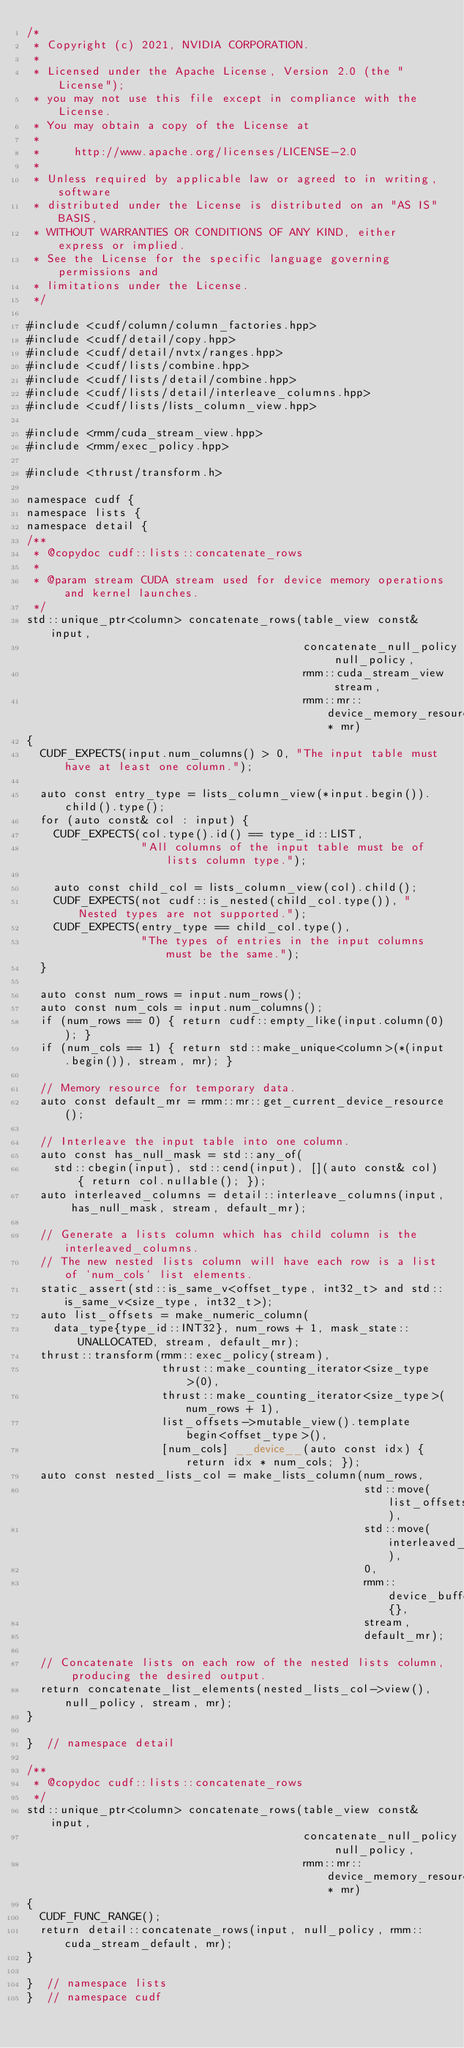<code> <loc_0><loc_0><loc_500><loc_500><_Cuda_>/*
 * Copyright (c) 2021, NVIDIA CORPORATION.
 *
 * Licensed under the Apache License, Version 2.0 (the "License");
 * you may not use this file except in compliance with the License.
 * You may obtain a copy of the License at
 *
 *     http://www.apache.org/licenses/LICENSE-2.0
 *
 * Unless required by applicable law or agreed to in writing, software
 * distributed under the License is distributed on an "AS IS" BASIS,
 * WITHOUT WARRANTIES OR CONDITIONS OF ANY KIND, either express or implied.
 * See the License for the specific language governing permissions and
 * limitations under the License.
 */

#include <cudf/column/column_factories.hpp>
#include <cudf/detail/copy.hpp>
#include <cudf/detail/nvtx/ranges.hpp>
#include <cudf/lists/combine.hpp>
#include <cudf/lists/detail/combine.hpp>
#include <cudf/lists/detail/interleave_columns.hpp>
#include <cudf/lists/lists_column_view.hpp>

#include <rmm/cuda_stream_view.hpp>
#include <rmm/exec_policy.hpp>

#include <thrust/transform.h>

namespace cudf {
namespace lists {
namespace detail {
/**
 * @copydoc cudf::lists::concatenate_rows
 *
 * @param stream CUDA stream used for device memory operations and kernel launches.
 */
std::unique_ptr<column> concatenate_rows(table_view const& input,
                                         concatenate_null_policy null_policy,
                                         rmm::cuda_stream_view stream,
                                         rmm::mr::device_memory_resource* mr)
{
  CUDF_EXPECTS(input.num_columns() > 0, "The input table must have at least one column.");

  auto const entry_type = lists_column_view(*input.begin()).child().type();
  for (auto const& col : input) {
    CUDF_EXPECTS(col.type().id() == type_id::LIST,
                 "All columns of the input table must be of lists column type.");

    auto const child_col = lists_column_view(col).child();
    CUDF_EXPECTS(not cudf::is_nested(child_col.type()), "Nested types are not supported.");
    CUDF_EXPECTS(entry_type == child_col.type(),
                 "The types of entries in the input columns must be the same.");
  }

  auto const num_rows = input.num_rows();
  auto const num_cols = input.num_columns();
  if (num_rows == 0) { return cudf::empty_like(input.column(0)); }
  if (num_cols == 1) { return std::make_unique<column>(*(input.begin()), stream, mr); }

  // Memory resource for temporary data.
  auto const default_mr = rmm::mr::get_current_device_resource();

  // Interleave the input table into one column.
  auto const has_null_mask = std::any_of(
    std::cbegin(input), std::cend(input), [](auto const& col) { return col.nullable(); });
  auto interleaved_columns = detail::interleave_columns(input, has_null_mask, stream, default_mr);

  // Generate a lists column which has child column is the interleaved_columns.
  // The new nested lists column will have each row is a list of `num_cols` list elements.
  static_assert(std::is_same_v<offset_type, int32_t> and std::is_same_v<size_type, int32_t>);
  auto list_offsets = make_numeric_column(
    data_type{type_id::INT32}, num_rows + 1, mask_state::UNALLOCATED, stream, default_mr);
  thrust::transform(rmm::exec_policy(stream),
                    thrust::make_counting_iterator<size_type>(0),
                    thrust::make_counting_iterator<size_type>(num_rows + 1),
                    list_offsets->mutable_view().template begin<offset_type>(),
                    [num_cols] __device__(auto const idx) { return idx * num_cols; });
  auto const nested_lists_col = make_lists_column(num_rows,
                                                  std::move(list_offsets),
                                                  std::move(interleaved_columns),
                                                  0,
                                                  rmm::device_buffer{},
                                                  stream,
                                                  default_mr);

  // Concatenate lists on each row of the nested lists column, producing the desired output.
  return concatenate_list_elements(nested_lists_col->view(), null_policy, stream, mr);
}

}  // namespace detail

/**
 * @copydoc cudf::lists::concatenate_rows
 */
std::unique_ptr<column> concatenate_rows(table_view const& input,
                                         concatenate_null_policy null_policy,
                                         rmm::mr::device_memory_resource* mr)
{
  CUDF_FUNC_RANGE();
  return detail::concatenate_rows(input, null_policy, rmm::cuda_stream_default, mr);
}

}  // namespace lists
}  // namespace cudf
</code> 